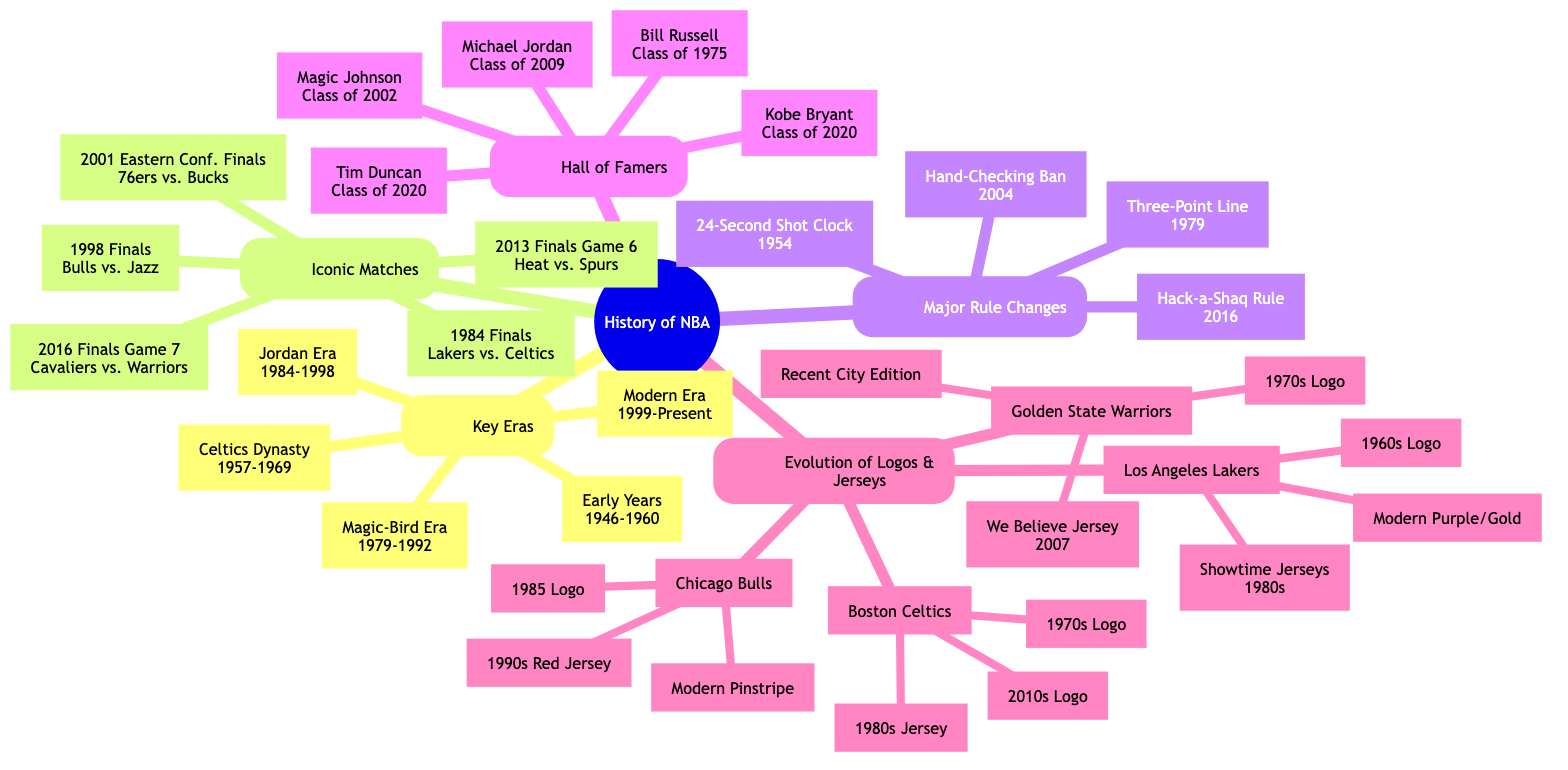What years define the Celtics Dynasty era? The diagram lists the eraser name "Celtics Dynasty" and directly states the years associated with it as "1957-1969."
Answer: 1957-1969 How many Hall of Famers are mentioned in the diagram? By counting the entries listed under "Hall of Famers," we see there are five individuals named in total.
Answer: 5 What iconic match features the Warriors in the diagram? The diagram includes "2016 Finals Game 7" representing the Cavaliers vs. Warriors match specifically indicating the team match-up with the Warriors included.
Answer: Cavaliers vs. Warriors What rule was introduced in 1979? The diagram states that the "Three-Point Line" was a major rule introduced in 1979, so we identify this specific rule from the listed changes.
Answer: Three-Point Line What team has a logo evolution from the 1970s to the 2010s? Focusing on "Boston Celtics" in the "Evolution of Team Logos and Jerseys," we see they have a logo progression moving from "1970s Logo" to "2010s Logo."
Answer: Boston Celtics 